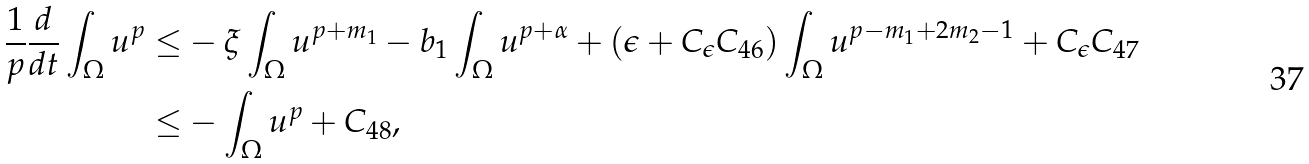<formula> <loc_0><loc_0><loc_500><loc_500>\frac { 1 } { p } \frac { d } { d t } \int _ { \Omega } u ^ { p } \leq & - \xi \int _ { \Omega } u ^ { p + m _ { 1 } } - b _ { 1 } \int _ { \Omega } u ^ { p + \alpha } + ( \epsilon + C _ { \epsilon } C _ { 4 6 } ) \int _ { \Omega } u ^ { p - m _ { 1 } + 2 m _ { 2 } - 1 } + C _ { \epsilon } C _ { 4 7 } \\ \leq & - \int _ { \Omega } u ^ { p } + C _ { 4 8 } ,</formula> 